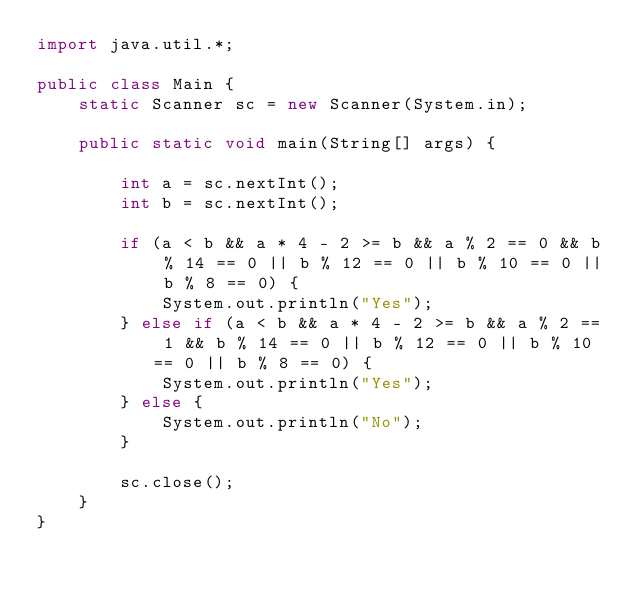Convert code to text. <code><loc_0><loc_0><loc_500><loc_500><_Java_>import java.util.*;

public class Main {
    static Scanner sc = new Scanner(System.in);

    public static void main(String[] args) {

        int a = sc.nextInt();
        int b = sc.nextInt();

        if (a < b && a * 4 - 2 >= b && a % 2 == 0 && b % 14 == 0 || b % 12 == 0 || b % 10 == 0 || b % 8 == 0) {
            System.out.println("Yes");
        } else if (a < b && a * 4 - 2 >= b && a % 2 == 1 && b % 14 == 0 || b % 12 == 0 || b % 10 == 0 || b % 8 == 0) {
            System.out.println("Yes");
        } else {
            System.out.println("No");
        }

        sc.close();
    }
}</code> 